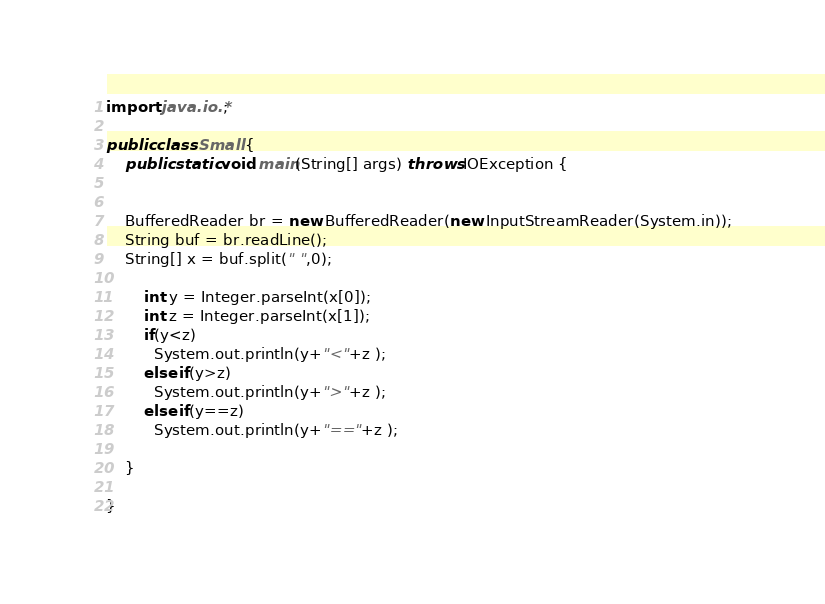Convert code to text. <code><loc_0><loc_0><loc_500><loc_500><_Java_>import java.io.*;  

public class Small {
    public static void main(String[] args) throws IOException {
	                                         
    	
	BufferedReader br = new BufferedReader(new InputStreamReader(System.in));
	String buf = br.readLine();
    String[] x = buf.split(" ",0);
    	
    	int y = Integer.parseInt(x[0]);
    	int z = Integer.parseInt(x[1]);
    	if(y<z)
          System.out.println(y+"<"+z ); 
    	else if(y>z)
          System.out.println(y+">"+z ); 
    	else if(y==z)
          System.out.println(y+"=="+z ); 
	    
    }
    
}</code> 